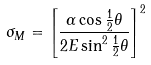<formula> <loc_0><loc_0><loc_500><loc_500>\sigma _ { M } = \left [ \frac { \alpha \cos \frac { 1 } { 2 } \theta } { 2 E \sin ^ { 2 } \frac { 1 } { 2 } \theta } \right ] ^ { 2 }</formula> 